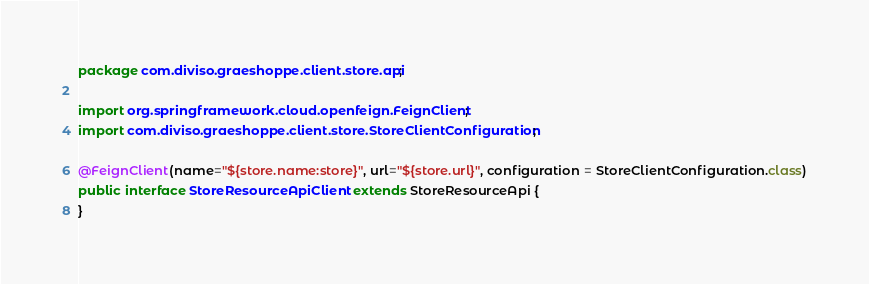Convert code to text. <code><loc_0><loc_0><loc_500><loc_500><_Java_>package com.diviso.graeshoppe.client.store.api;

import org.springframework.cloud.openfeign.FeignClient;
import com.diviso.graeshoppe.client.store.StoreClientConfiguration;

@FeignClient(name="${store.name:store}", url="${store.url}", configuration = StoreClientConfiguration.class)
public interface StoreResourceApiClient extends StoreResourceApi {
}</code> 